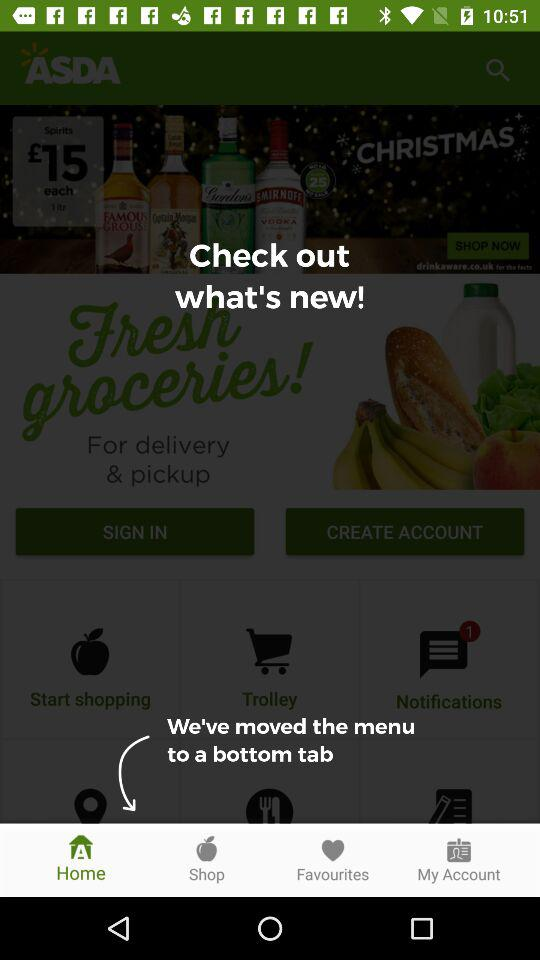Which tab is selected? The selected tab is "Home". 